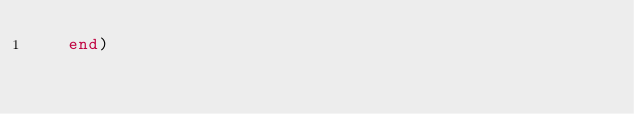Convert code to text. <code><loc_0><loc_0><loc_500><loc_500><_SML_>   end)
</code> 